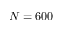Convert formula to latex. <formula><loc_0><loc_0><loc_500><loc_500>N = 6 0 0</formula> 